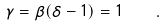Convert formula to latex. <formula><loc_0><loc_0><loc_500><loc_500>\gamma = \beta ( \delta - 1 ) = 1 \quad .</formula> 